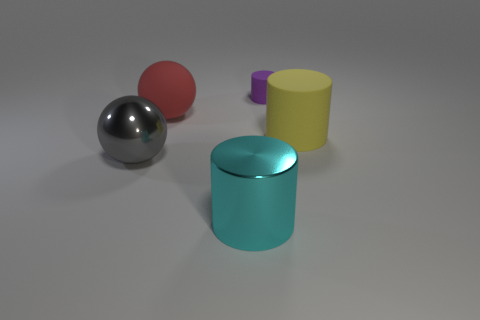There is a matte object that is in front of the sphere behind the matte cylinder right of the tiny rubber cylinder; how big is it?
Keep it short and to the point. Large. What number of objects are either large things that are to the left of the large red thing or things that are left of the large red matte thing?
Ensure brevity in your answer.  1. The large gray thing has what shape?
Make the answer very short. Sphere. How many other objects are the same material as the big red thing?
Offer a very short reply. 2. What is the size of the other object that is the same shape as the gray metallic thing?
Give a very brief answer. Large. What material is the large object that is to the right of the cylinder in front of the ball that is in front of the large yellow rubber object?
Your answer should be compact. Rubber. Are there any cyan cylinders?
Make the answer very short. Yes. Do the small thing and the big cylinder to the right of the cyan object have the same color?
Give a very brief answer. No. What color is the small matte thing?
Keep it short and to the point. Purple. Is there any other thing that has the same shape as the red rubber thing?
Your answer should be compact. Yes. 